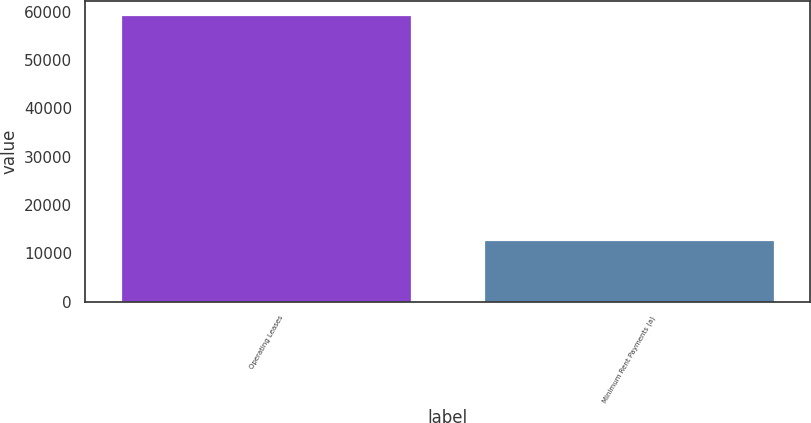<chart> <loc_0><loc_0><loc_500><loc_500><bar_chart><fcel>Operating Leases<fcel>Minimum Rent Payments (a)<nl><fcel>59259<fcel>12810<nl></chart> 